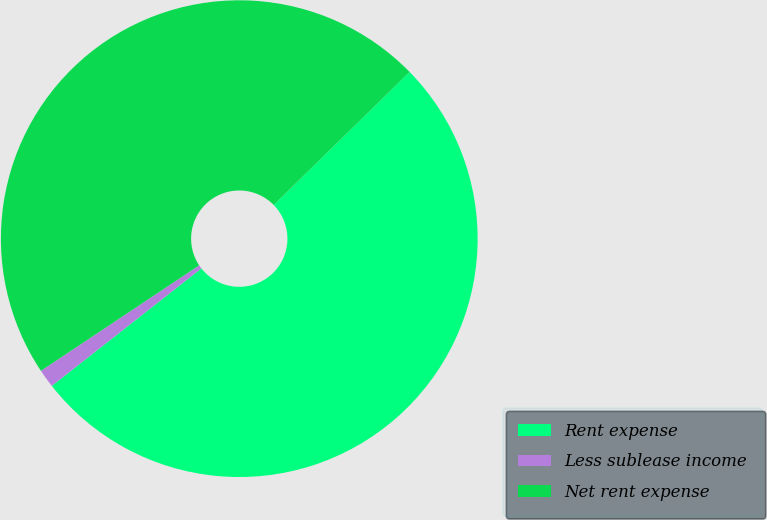Convert chart. <chart><loc_0><loc_0><loc_500><loc_500><pie_chart><fcel>Rent expense<fcel>Less sublease income<fcel>Net rent expense<nl><fcel>51.73%<fcel>1.24%<fcel>47.03%<nl></chart> 